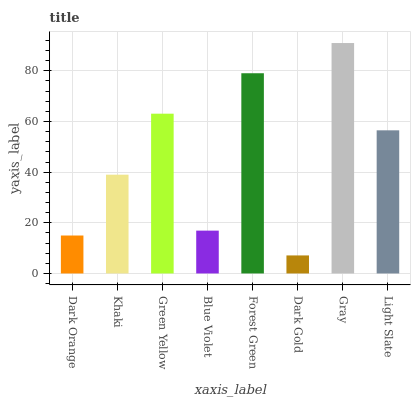Is Dark Gold the minimum?
Answer yes or no. Yes. Is Gray the maximum?
Answer yes or no. Yes. Is Khaki the minimum?
Answer yes or no. No. Is Khaki the maximum?
Answer yes or no. No. Is Khaki greater than Dark Orange?
Answer yes or no. Yes. Is Dark Orange less than Khaki?
Answer yes or no. Yes. Is Dark Orange greater than Khaki?
Answer yes or no. No. Is Khaki less than Dark Orange?
Answer yes or no. No. Is Light Slate the high median?
Answer yes or no. Yes. Is Khaki the low median?
Answer yes or no. Yes. Is Khaki the high median?
Answer yes or no. No. Is Forest Green the low median?
Answer yes or no. No. 